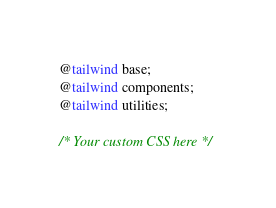Convert code to text. <code><loc_0><loc_0><loc_500><loc_500><_CSS_>@tailwind base;
@tailwind components;
@tailwind utilities;

/* Your custom CSS here */
</code> 